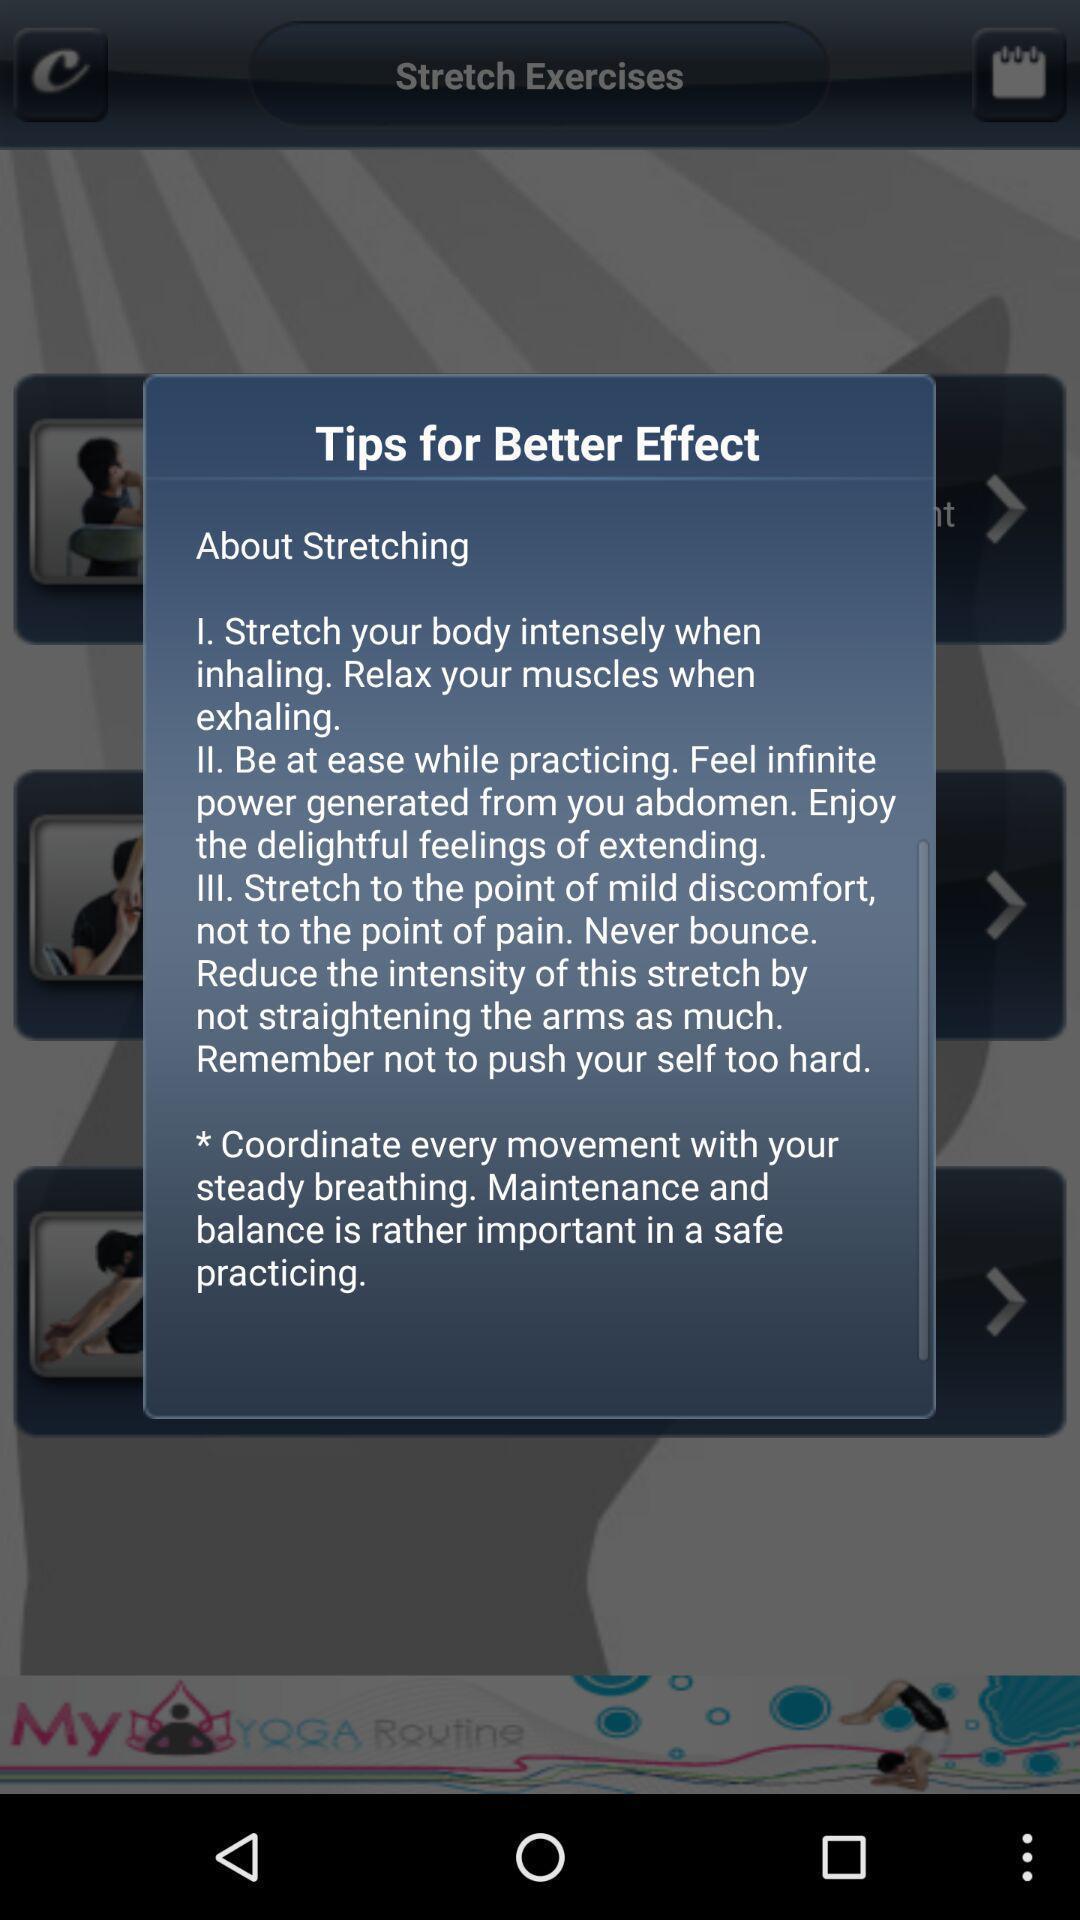Give me a narrative description of this picture. Pop-up showing tips for better effects in the app. 